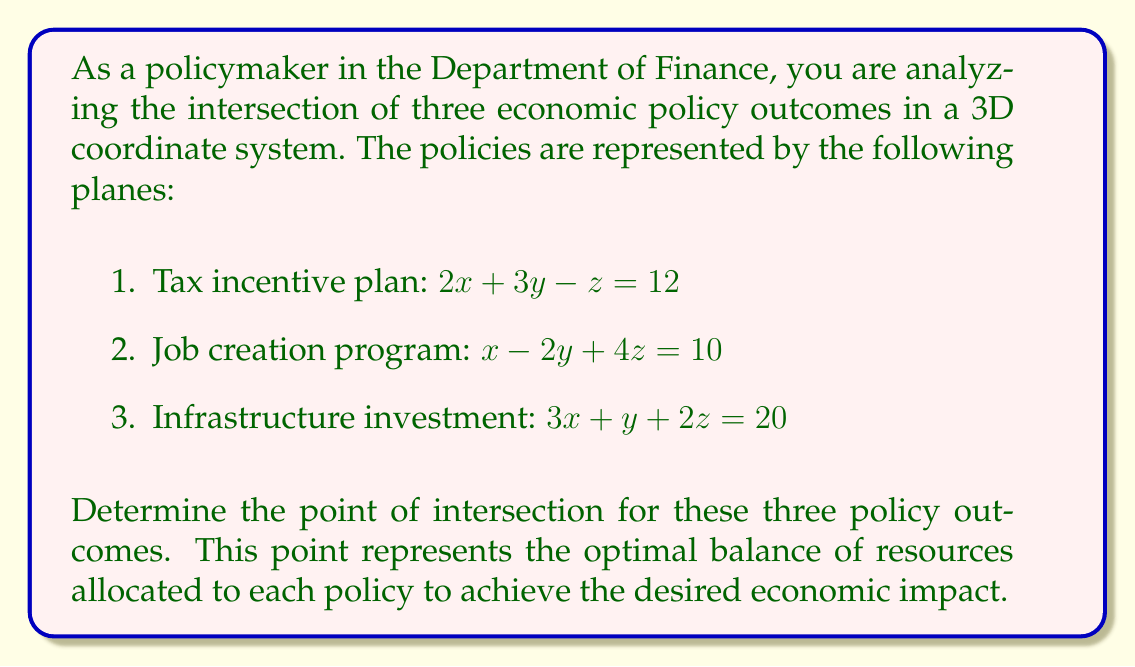Could you help me with this problem? To find the intersection point of the three planes, we need to solve the system of linear equations:

$$
\begin{cases}
2x + 3y - z = 12 \\
x - 2y + 4z = 10 \\
3x + y + 2z = 20
\end{cases}
$$

We can solve this system using the elimination method:

1. Multiply the first equation by 2 and the second equation by 3:
   $$
   \begin{cases}
   4x + 6y - 2z = 24 \\
   3x - 6y + 12z = 30 \\
   3x + y + 2z = 20
   \end{cases}
   $$

2. Add the first two equations to eliminate y:
   $$7x + 10z = 54 \quad (1)$$

3. Now, multiply the original first equation by 3 and the third equation by 2:
   $$
   \begin{cases}
   6x + 9y - 3z = 36 \\
   6x + 2y + 4z = 40
   \end{cases}
   $$

4. Subtract the second equation from the first to eliminate x:
   $$7y - 7z = -4 \quad (2)$$

5. From equation (2), we can express y in terms of z:
   $$y = z - \frac{4}{7} \quad (3)$$

6. Substitute this into the original first equation:
   $$2x + 3(z - \frac{4}{7}) - z = 12$$
   $$2x + 2z - \frac{12}{7} = 12$$
   $$2x + 2z = \frac{96}{7} \quad (4)$$

7. Now we have equations (1) and (4). Multiply (4) by 7 and subtract it from (1) multiplied by 2:
   $$14x + 20z = 108$$
   $$14x + 14z = 96$$
   $$6z = 12$$
   $$z = 2$$

8. Substitute z = 2 into equation (3):
   $$y = 2 - \frac{4}{7} = \frac{10}{7}$$

9. Substitute z = 2 and y = 10/7 into the original first equation:
   $$2x + 3(\frac{10}{7}) - 2 = 12$$
   $$2x + \frac{30}{7} - 2 = 12$$
   $$2x = 12 - \frac{30}{7} + 2 = \frac{70}{7}$$
   $$x = \frac{35}{7} = 5$$

Therefore, the intersection point is $(5, \frac{10}{7}, 2)$.
Answer: The point of intersection for the three economic policy outcomes is $(\frac{35}{7}, \frac{10}{7}, 2)$ or approximately $(5, 1.43, 2)$. 